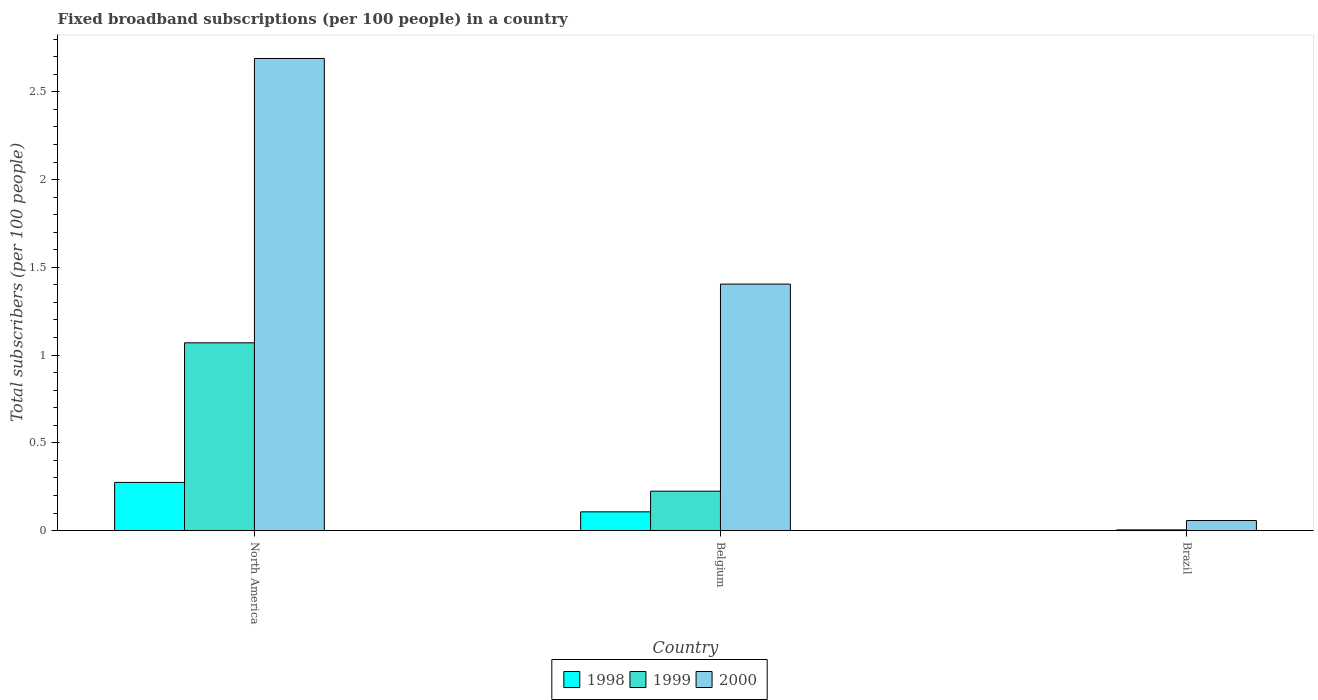How many different coloured bars are there?
Provide a succinct answer. 3. Are the number of bars per tick equal to the number of legend labels?
Keep it short and to the point. Yes. How many bars are there on the 1st tick from the right?
Offer a very short reply. 3. In how many cases, is the number of bars for a given country not equal to the number of legend labels?
Your answer should be very brief. 0. What is the number of broadband subscriptions in 1999 in Brazil?
Offer a terse response. 0. Across all countries, what is the maximum number of broadband subscriptions in 1999?
Your answer should be compact. 1.07. Across all countries, what is the minimum number of broadband subscriptions in 1999?
Provide a succinct answer. 0. In which country was the number of broadband subscriptions in 2000 maximum?
Make the answer very short. North America. In which country was the number of broadband subscriptions in 2000 minimum?
Keep it short and to the point. Brazil. What is the total number of broadband subscriptions in 2000 in the graph?
Provide a short and direct response. 4.15. What is the difference between the number of broadband subscriptions in 1998 in Brazil and that in North America?
Provide a short and direct response. -0.27. What is the difference between the number of broadband subscriptions in 1998 in Belgium and the number of broadband subscriptions in 1999 in North America?
Keep it short and to the point. -0.96. What is the average number of broadband subscriptions in 2000 per country?
Make the answer very short. 1.38. What is the difference between the number of broadband subscriptions of/in 1998 and number of broadband subscriptions of/in 2000 in North America?
Make the answer very short. -2.42. In how many countries, is the number of broadband subscriptions in 1998 greater than 1.8?
Your answer should be very brief. 0. What is the ratio of the number of broadband subscriptions in 1998 in Belgium to that in Brazil?
Give a very brief answer. 181.1. Is the number of broadband subscriptions in 1999 in Brazil less than that in North America?
Your answer should be very brief. Yes. What is the difference between the highest and the second highest number of broadband subscriptions in 1998?
Your answer should be very brief. 0.17. What is the difference between the highest and the lowest number of broadband subscriptions in 2000?
Give a very brief answer. 2.63. In how many countries, is the number of broadband subscriptions in 2000 greater than the average number of broadband subscriptions in 2000 taken over all countries?
Provide a succinct answer. 2. What does the 3rd bar from the left in North America represents?
Provide a succinct answer. 2000. What does the 3rd bar from the right in North America represents?
Ensure brevity in your answer.  1998. Is it the case that in every country, the sum of the number of broadband subscriptions in 1998 and number of broadband subscriptions in 1999 is greater than the number of broadband subscriptions in 2000?
Offer a very short reply. No. Are all the bars in the graph horizontal?
Provide a succinct answer. No. Does the graph contain grids?
Your answer should be compact. No. Where does the legend appear in the graph?
Ensure brevity in your answer.  Bottom center. How many legend labels are there?
Offer a very short reply. 3. What is the title of the graph?
Your answer should be compact. Fixed broadband subscriptions (per 100 people) in a country. Does "1970" appear as one of the legend labels in the graph?
Keep it short and to the point. No. What is the label or title of the X-axis?
Provide a succinct answer. Country. What is the label or title of the Y-axis?
Provide a short and direct response. Total subscribers (per 100 people). What is the Total subscribers (per 100 people) of 1998 in North America?
Provide a short and direct response. 0.27. What is the Total subscribers (per 100 people) of 1999 in North America?
Keep it short and to the point. 1.07. What is the Total subscribers (per 100 people) of 2000 in North America?
Offer a terse response. 2.69. What is the Total subscribers (per 100 people) in 1998 in Belgium?
Ensure brevity in your answer.  0.11. What is the Total subscribers (per 100 people) in 1999 in Belgium?
Your answer should be compact. 0.22. What is the Total subscribers (per 100 people) in 2000 in Belgium?
Make the answer very short. 1.4. What is the Total subscribers (per 100 people) in 1998 in Brazil?
Make the answer very short. 0. What is the Total subscribers (per 100 people) in 1999 in Brazil?
Your answer should be very brief. 0. What is the Total subscribers (per 100 people) of 2000 in Brazil?
Keep it short and to the point. 0.06. Across all countries, what is the maximum Total subscribers (per 100 people) in 1998?
Provide a succinct answer. 0.27. Across all countries, what is the maximum Total subscribers (per 100 people) of 1999?
Your response must be concise. 1.07. Across all countries, what is the maximum Total subscribers (per 100 people) of 2000?
Offer a very short reply. 2.69. Across all countries, what is the minimum Total subscribers (per 100 people) of 1998?
Provide a succinct answer. 0. Across all countries, what is the minimum Total subscribers (per 100 people) of 1999?
Your response must be concise. 0. Across all countries, what is the minimum Total subscribers (per 100 people) of 2000?
Ensure brevity in your answer.  0.06. What is the total Total subscribers (per 100 people) of 1998 in the graph?
Your answer should be compact. 0.38. What is the total Total subscribers (per 100 people) of 1999 in the graph?
Offer a very short reply. 1.3. What is the total Total subscribers (per 100 people) in 2000 in the graph?
Ensure brevity in your answer.  4.15. What is the difference between the Total subscribers (per 100 people) in 1998 in North America and that in Belgium?
Provide a short and direct response. 0.17. What is the difference between the Total subscribers (per 100 people) of 1999 in North America and that in Belgium?
Your answer should be compact. 0.85. What is the difference between the Total subscribers (per 100 people) in 2000 in North America and that in Belgium?
Provide a succinct answer. 1.29. What is the difference between the Total subscribers (per 100 people) in 1998 in North America and that in Brazil?
Your answer should be very brief. 0.27. What is the difference between the Total subscribers (per 100 people) of 1999 in North America and that in Brazil?
Make the answer very short. 1.07. What is the difference between the Total subscribers (per 100 people) in 2000 in North America and that in Brazil?
Your response must be concise. 2.63. What is the difference between the Total subscribers (per 100 people) of 1998 in Belgium and that in Brazil?
Keep it short and to the point. 0.11. What is the difference between the Total subscribers (per 100 people) of 1999 in Belgium and that in Brazil?
Provide a short and direct response. 0.22. What is the difference between the Total subscribers (per 100 people) in 2000 in Belgium and that in Brazil?
Ensure brevity in your answer.  1.35. What is the difference between the Total subscribers (per 100 people) in 1998 in North America and the Total subscribers (per 100 people) in 1999 in Belgium?
Provide a succinct answer. 0.05. What is the difference between the Total subscribers (per 100 people) of 1998 in North America and the Total subscribers (per 100 people) of 2000 in Belgium?
Offer a very short reply. -1.13. What is the difference between the Total subscribers (per 100 people) of 1999 in North America and the Total subscribers (per 100 people) of 2000 in Belgium?
Keep it short and to the point. -0.33. What is the difference between the Total subscribers (per 100 people) of 1998 in North America and the Total subscribers (per 100 people) of 1999 in Brazil?
Offer a terse response. 0.27. What is the difference between the Total subscribers (per 100 people) in 1998 in North America and the Total subscribers (per 100 people) in 2000 in Brazil?
Offer a very short reply. 0.22. What is the difference between the Total subscribers (per 100 people) in 1999 in North America and the Total subscribers (per 100 people) in 2000 in Brazil?
Your response must be concise. 1.01. What is the difference between the Total subscribers (per 100 people) in 1998 in Belgium and the Total subscribers (per 100 people) in 1999 in Brazil?
Ensure brevity in your answer.  0.1. What is the difference between the Total subscribers (per 100 people) of 1998 in Belgium and the Total subscribers (per 100 people) of 2000 in Brazil?
Your response must be concise. 0.05. What is the difference between the Total subscribers (per 100 people) in 1999 in Belgium and the Total subscribers (per 100 people) in 2000 in Brazil?
Give a very brief answer. 0.17. What is the average Total subscribers (per 100 people) in 1998 per country?
Your answer should be very brief. 0.13. What is the average Total subscribers (per 100 people) in 1999 per country?
Your answer should be compact. 0.43. What is the average Total subscribers (per 100 people) in 2000 per country?
Give a very brief answer. 1.38. What is the difference between the Total subscribers (per 100 people) of 1998 and Total subscribers (per 100 people) of 1999 in North America?
Make the answer very short. -0.8. What is the difference between the Total subscribers (per 100 people) in 1998 and Total subscribers (per 100 people) in 2000 in North America?
Offer a very short reply. -2.42. What is the difference between the Total subscribers (per 100 people) in 1999 and Total subscribers (per 100 people) in 2000 in North America?
Your response must be concise. -1.62. What is the difference between the Total subscribers (per 100 people) in 1998 and Total subscribers (per 100 people) in 1999 in Belgium?
Make the answer very short. -0.12. What is the difference between the Total subscribers (per 100 people) in 1998 and Total subscribers (per 100 people) in 2000 in Belgium?
Provide a short and direct response. -1.3. What is the difference between the Total subscribers (per 100 people) in 1999 and Total subscribers (per 100 people) in 2000 in Belgium?
Your answer should be very brief. -1.18. What is the difference between the Total subscribers (per 100 people) in 1998 and Total subscribers (per 100 people) in 1999 in Brazil?
Make the answer very short. -0. What is the difference between the Total subscribers (per 100 people) in 1998 and Total subscribers (per 100 people) in 2000 in Brazil?
Your response must be concise. -0.06. What is the difference between the Total subscribers (per 100 people) of 1999 and Total subscribers (per 100 people) of 2000 in Brazil?
Keep it short and to the point. -0.05. What is the ratio of the Total subscribers (per 100 people) in 1998 in North America to that in Belgium?
Provide a short and direct response. 2.57. What is the ratio of the Total subscribers (per 100 people) of 1999 in North America to that in Belgium?
Your response must be concise. 4.76. What is the ratio of the Total subscribers (per 100 people) of 2000 in North America to that in Belgium?
Provide a short and direct response. 1.92. What is the ratio of the Total subscribers (per 100 people) in 1998 in North America to that in Brazil?
Give a very brief answer. 465.15. What is the ratio of the Total subscribers (per 100 people) in 1999 in North America to that in Brazil?
Give a very brief answer. 262.9. What is the ratio of the Total subscribers (per 100 people) of 2000 in North America to that in Brazil?
Give a very brief answer. 46.94. What is the ratio of the Total subscribers (per 100 people) in 1998 in Belgium to that in Brazil?
Your answer should be compact. 181.1. What is the ratio of the Total subscribers (per 100 people) in 1999 in Belgium to that in Brazil?
Give a very brief answer. 55.18. What is the ratio of the Total subscribers (per 100 people) in 2000 in Belgium to that in Brazil?
Provide a short and direct response. 24.51. What is the difference between the highest and the second highest Total subscribers (per 100 people) in 1998?
Provide a succinct answer. 0.17. What is the difference between the highest and the second highest Total subscribers (per 100 people) of 1999?
Your answer should be very brief. 0.85. What is the difference between the highest and the second highest Total subscribers (per 100 people) in 2000?
Give a very brief answer. 1.29. What is the difference between the highest and the lowest Total subscribers (per 100 people) of 1998?
Your answer should be very brief. 0.27. What is the difference between the highest and the lowest Total subscribers (per 100 people) of 1999?
Keep it short and to the point. 1.07. What is the difference between the highest and the lowest Total subscribers (per 100 people) of 2000?
Your response must be concise. 2.63. 